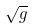Convert formula to latex. <formula><loc_0><loc_0><loc_500><loc_500>\sqrt { g }</formula> 